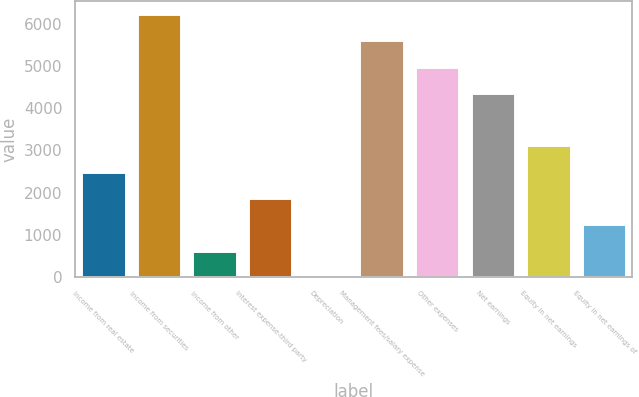Convert chart. <chart><loc_0><loc_0><loc_500><loc_500><bar_chart><fcel>Income from real estate<fcel>Income from securities<fcel>Income from other<fcel>Interest expense-third party<fcel>Depreciation<fcel>Management fees/salary expense<fcel>Other expenses<fcel>Net earnings<fcel>Equity in net earnings<fcel>Equity in net earnings of<nl><fcel>2495.8<fcel>6238<fcel>624.7<fcel>1872.1<fcel>1<fcel>5614.3<fcel>4990.6<fcel>4366.9<fcel>3119.5<fcel>1248.4<nl></chart> 